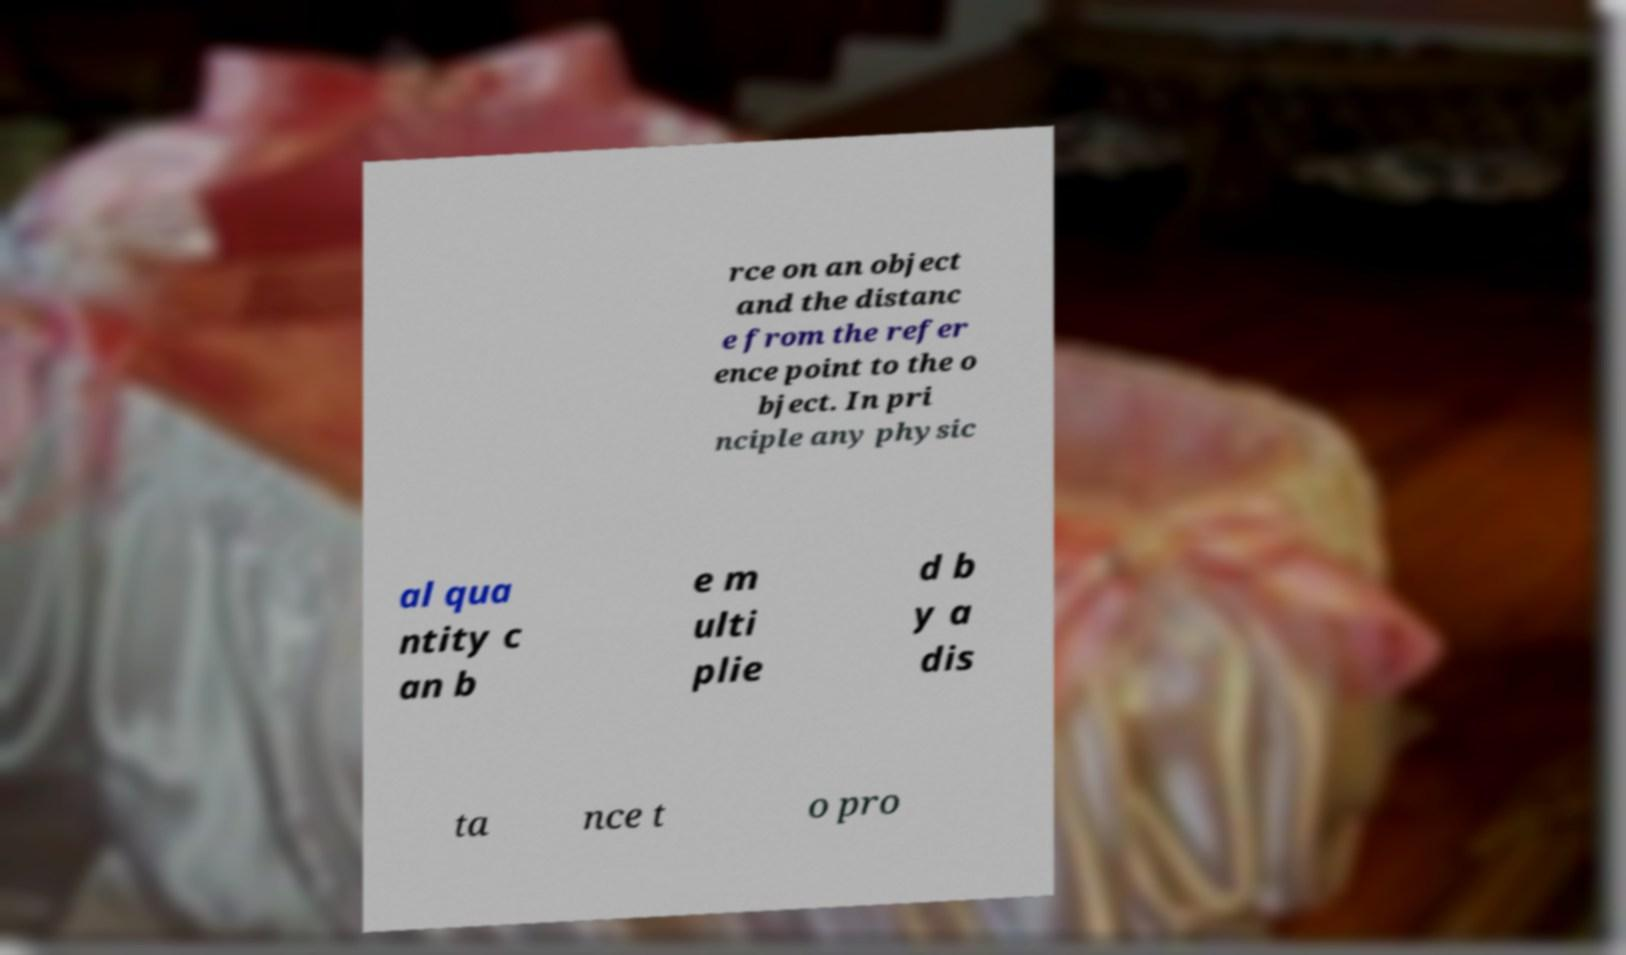There's text embedded in this image that I need extracted. Can you transcribe it verbatim? rce on an object and the distanc e from the refer ence point to the o bject. In pri nciple any physic al qua ntity c an b e m ulti plie d b y a dis ta nce t o pro 